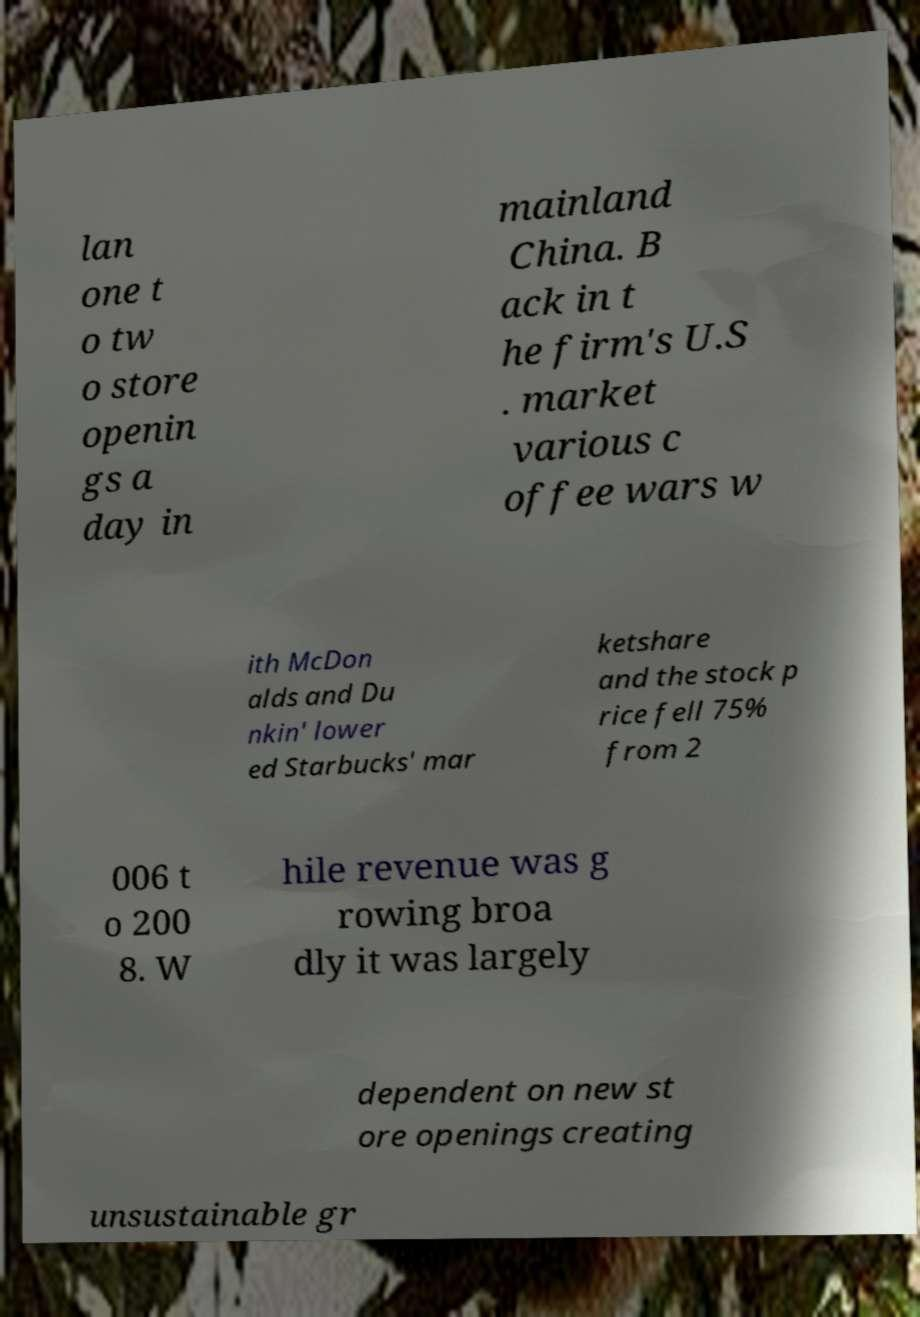There's text embedded in this image that I need extracted. Can you transcribe it verbatim? lan one t o tw o store openin gs a day in mainland China. B ack in t he firm's U.S . market various c offee wars w ith McDon alds and Du nkin' lower ed Starbucks' mar ketshare and the stock p rice fell 75% from 2 006 t o 200 8. W hile revenue was g rowing broa dly it was largely dependent on new st ore openings creating unsustainable gr 